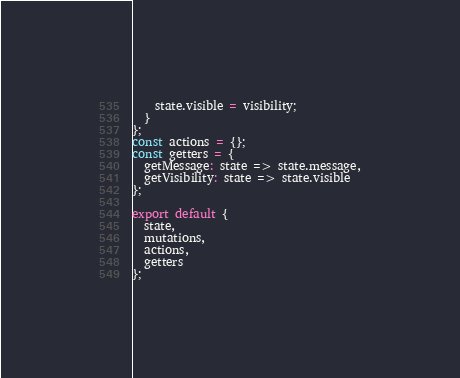<code> <loc_0><loc_0><loc_500><loc_500><_JavaScript_>    state.visible = visibility;
  }
};
const actions = {};
const getters = {
  getMessage: state => state.message,
  getVisibility: state => state.visible
};

export default {
  state,
  mutations,
  actions,
  getters
};
</code> 